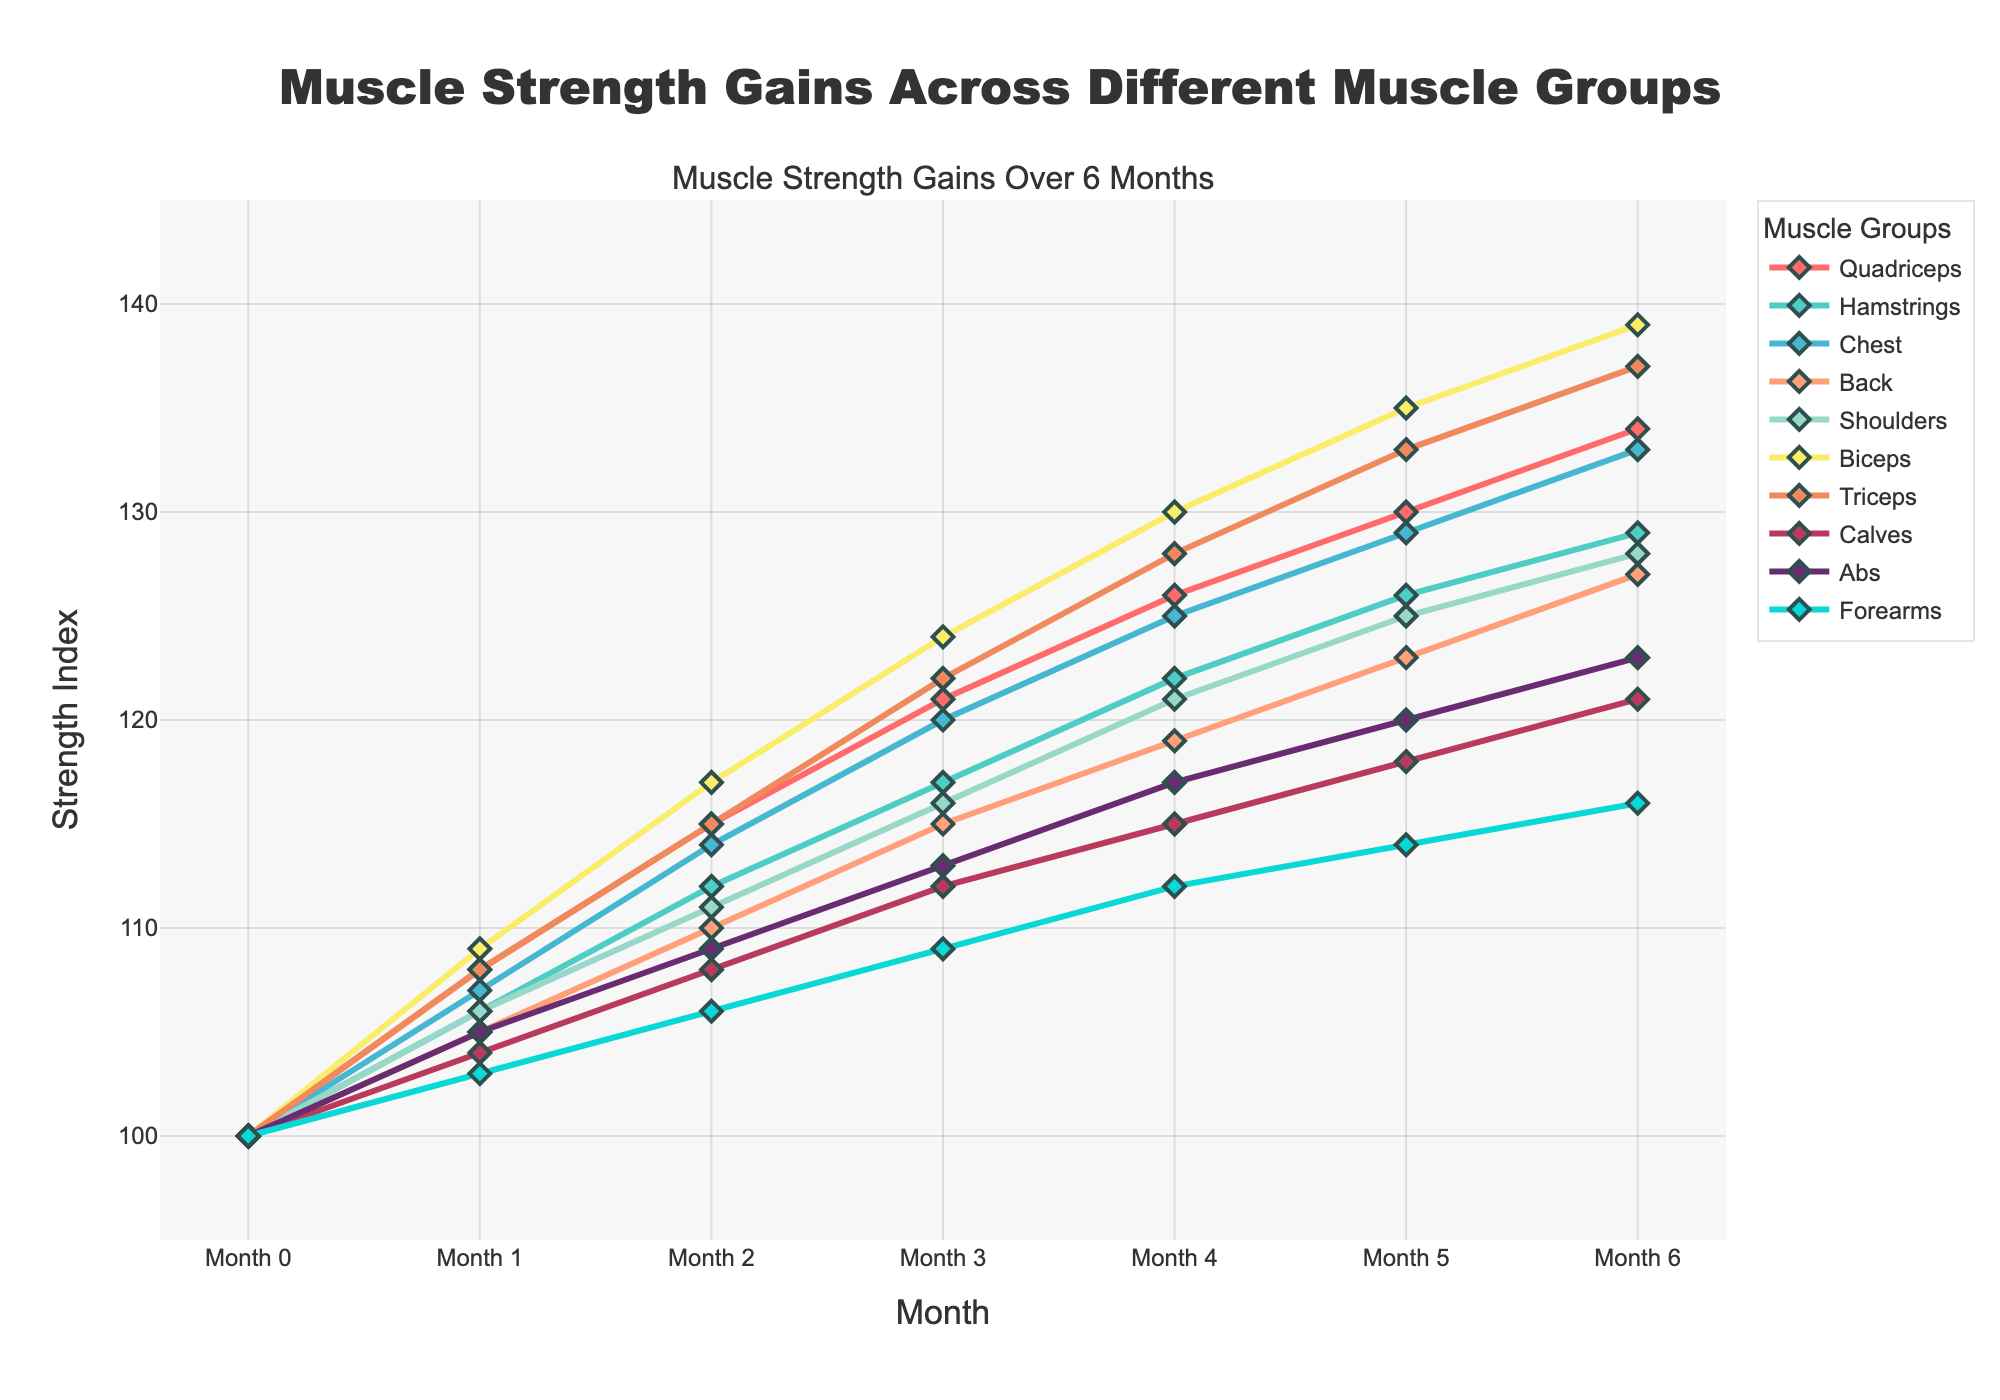What's the overall trend for muscle strength gains across all muscle groups? All muscle groups show an upward trend in muscle strength gains over the 6-month period, indicating a consistent improvement in strength across all groups.
Answer: Upward trend Which muscle group shows the highest strength gain by month 6? Looking at the strength values for month 6, the Biceps have the highest value at 139.
Answer: Biceps How do the strength gains for the Quadriceps in month 3 compare to those for the Hamstrings in month 3? The Quadriceps have a strength value of 121 in month 3, while the Hamstrings have a strength value of 117. Comparing these values, the Quadriceps have slightly higher strength gains than the Hamstrings.
Answer: Quadriceps have higher gains What is the average strength index of the Shoulders over the 6-month period? The strength indices for the Shoulders are [100, 106, 111, 116, 121, 125, 128]. Summing these values gives 807, and dividing by the number of months (7) results in an average of 115.3.
Answer: 115.3 Which two muscle groups have the closest strength indices in the final month? In month 6, the Hamstrings and Shoulders have strength indices of 129 and 128, respectively, which are the closest in value.
Answer: Hamstrings and Shoulders How much total strength gain did the Chest experience from month 0 to month 6? The strength index for the Chest increased from 100 in month 0 to 133 in month 6. The total strength gain is 133 - 100 = 33.
Answer: 33 Compare the visual markers for the Biceps and Forearms. Which has larger markers, and what is the significance? The Biceps have larger markers than the Forearms, signifying potentially higher emphasis or greater strength gains relative to initial values.
Answer: Biceps What muscle group shows the smallest improvement by month 6? By month 6, the Forearms have the smallest strength index increase, reaching only 116 from an initial value of 100.
Answer: Forearms What is the percentage increase in strength for the Abs from month 0 to month 6? The Abs increased from 100 to 123 over the 6-month period. The percentage increase is ((123 - 100) / 100) * 100 = 23%.
Answer: 23% 